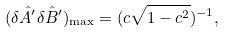Convert formula to latex. <formula><loc_0><loc_0><loc_500><loc_500>( \delta \hat { A } ^ { \prime } \delta \hat { B } ^ { \prime } ) _ { \max } = ( c \sqrt { 1 - c ^ { 2 } } ) ^ { - 1 } ,</formula> 